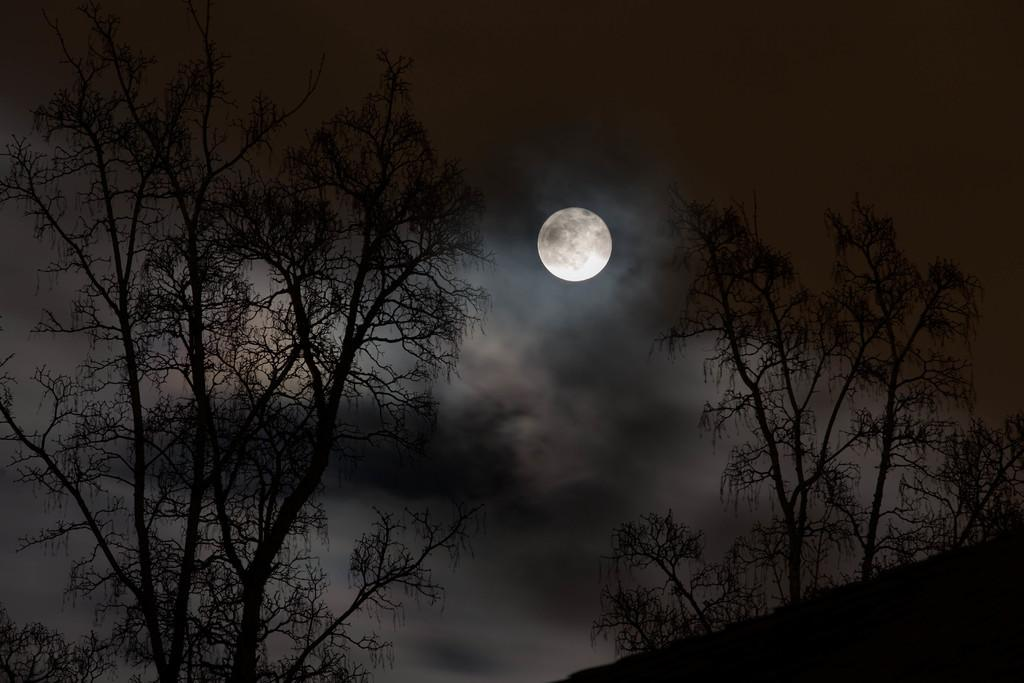Where was the picture taken? The picture was clicked outside. What can be seen in the foreground of the image? There are trees and the ground visible in the foreground of the image. What is present in the sky in the image? There is a moon in the sky in the center of the image, and the sky is full of clouds. What type of whistle can be heard in the image? There is no whistle present in the image, as it is a still photograph and does not contain any sounds. 